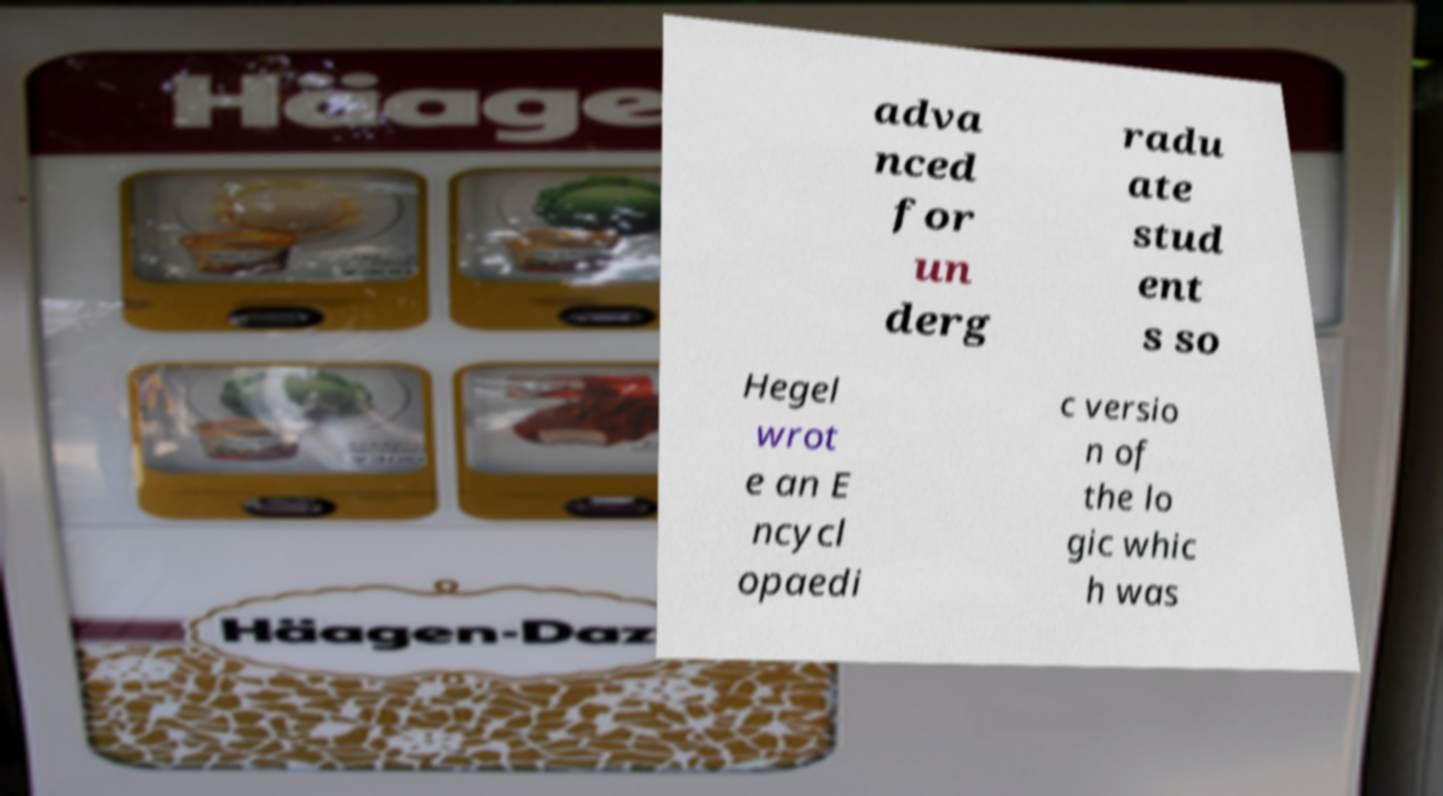Could you extract and type out the text from this image? adva nced for un derg radu ate stud ent s so Hegel wrot e an E ncycl opaedi c versio n of the lo gic whic h was 